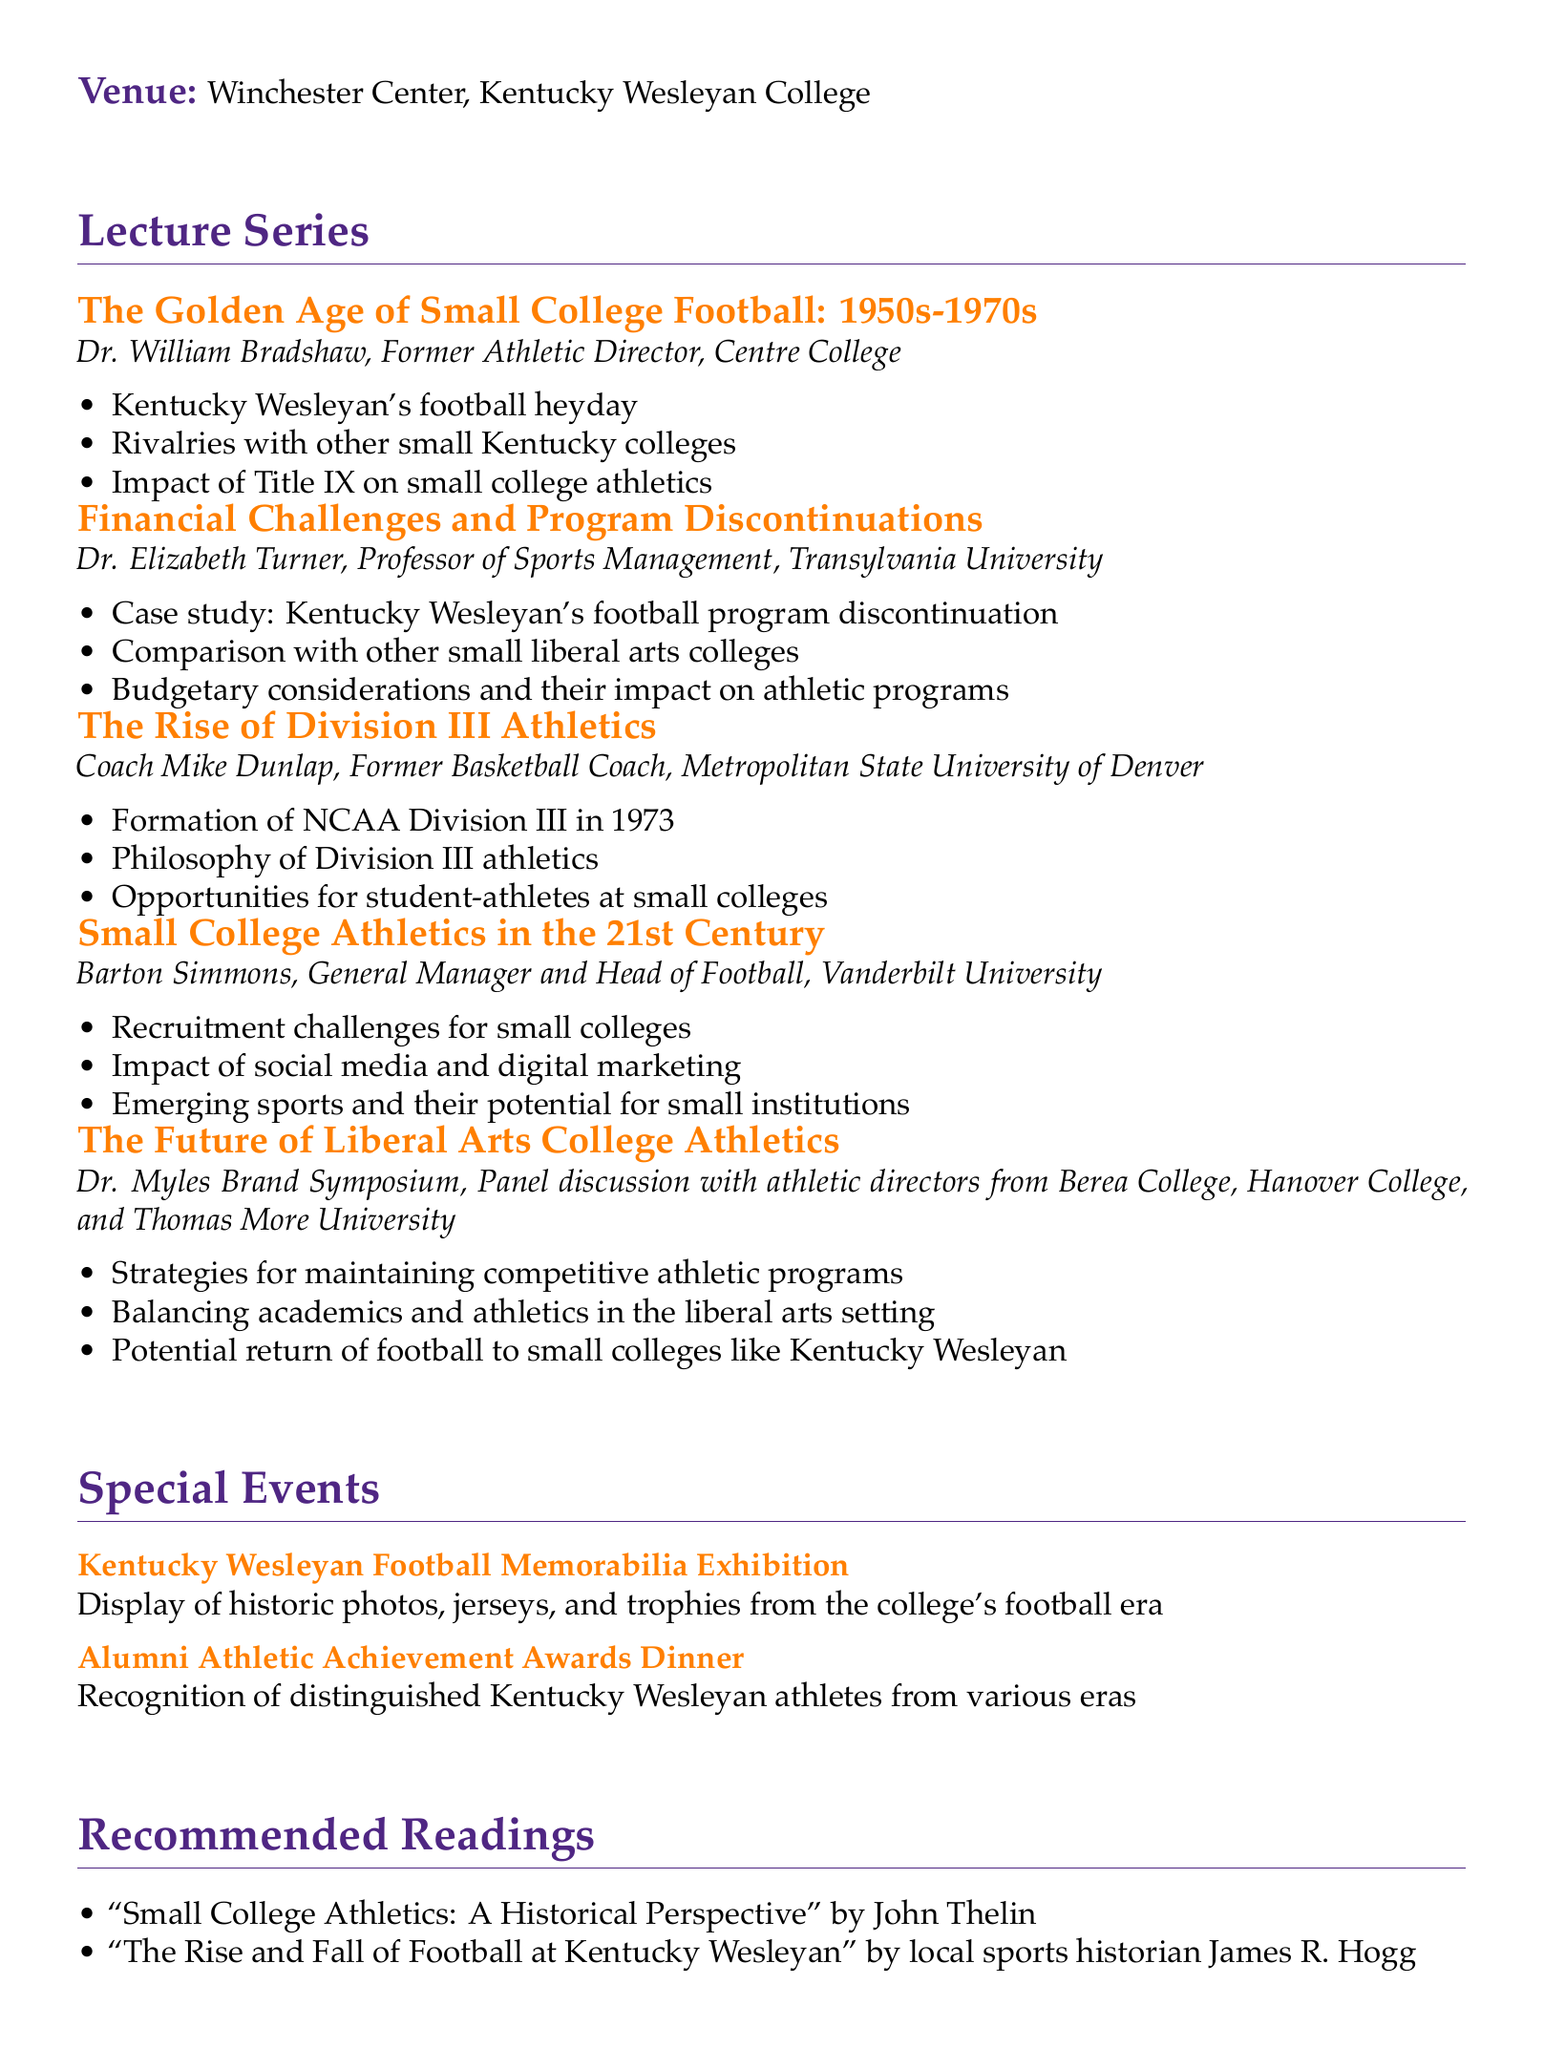What is the title of the lecture series? The title of the lecture series is mentioned at the beginning of the document as "Small College Athletics: Past, Present, and Future."
Answer: Small College Athletics: Past, Present, and Future Who is the speaker for the lecture on financial challenges? The document specifies that Dr. Elizabeth Turner is the speaker addressing financial challenges and program discontinuations.
Answer: Dr. Elizabeth Turner What is one of the key points discussed in the lecture by Dr. William Bradshaw? The key points in Dr. William Bradshaw's lecture include discussions about Kentucky Wesleyan's football heyday and rivalries.
Answer: Kentucky Wesleyan's football heyday Where is the venue for the guest lecture series? The venue for the lecture series is stated in the document as Winchester Center, Kentucky Wesleyan College.
Answer: Winchester Center, Kentucky Wesleyan College What is a special event included in the agenda? The document lists a special event, which is the Kentucky Wesleyan Football Memorabilia Exhibition, showcasing historic items from the football era.
Answer: Kentucky Wesleyan Football Memorabilia Exhibition What year was NCAA Division III formed? The document mentions that NCAA Division III was formed in 1973 during Coach Mike Dunlap's lecture.
Answer: 1973 Who are the participants in the panel discussion about the future of liberal arts college athletics? The document indicates that the panel includes athletic directors from Berea College, Hanover College, and Thomas More University.
Answer: Berea College, Hanover College, and Thomas More University What type of readings are recommended? The document specifies that the recommended readings include historical perspectives and analyses related to small college athletics.
Answer: Historical perspectives and analyses 